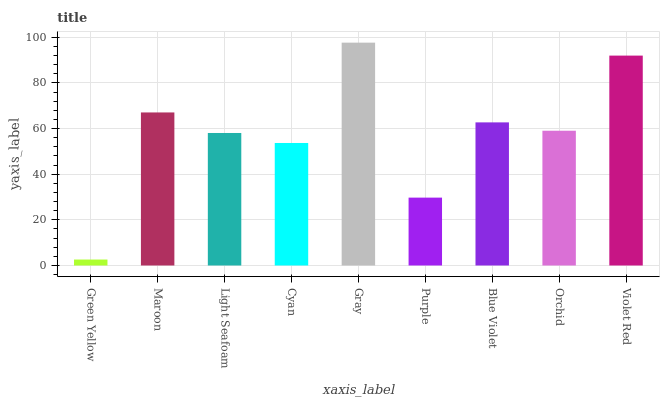Is Green Yellow the minimum?
Answer yes or no. Yes. Is Gray the maximum?
Answer yes or no. Yes. Is Maroon the minimum?
Answer yes or no. No. Is Maroon the maximum?
Answer yes or no. No. Is Maroon greater than Green Yellow?
Answer yes or no. Yes. Is Green Yellow less than Maroon?
Answer yes or no. Yes. Is Green Yellow greater than Maroon?
Answer yes or no. No. Is Maroon less than Green Yellow?
Answer yes or no. No. Is Orchid the high median?
Answer yes or no. Yes. Is Orchid the low median?
Answer yes or no. Yes. Is Gray the high median?
Answer yes or no. No. Is Gray the low median?
Answer yes or no. No. 